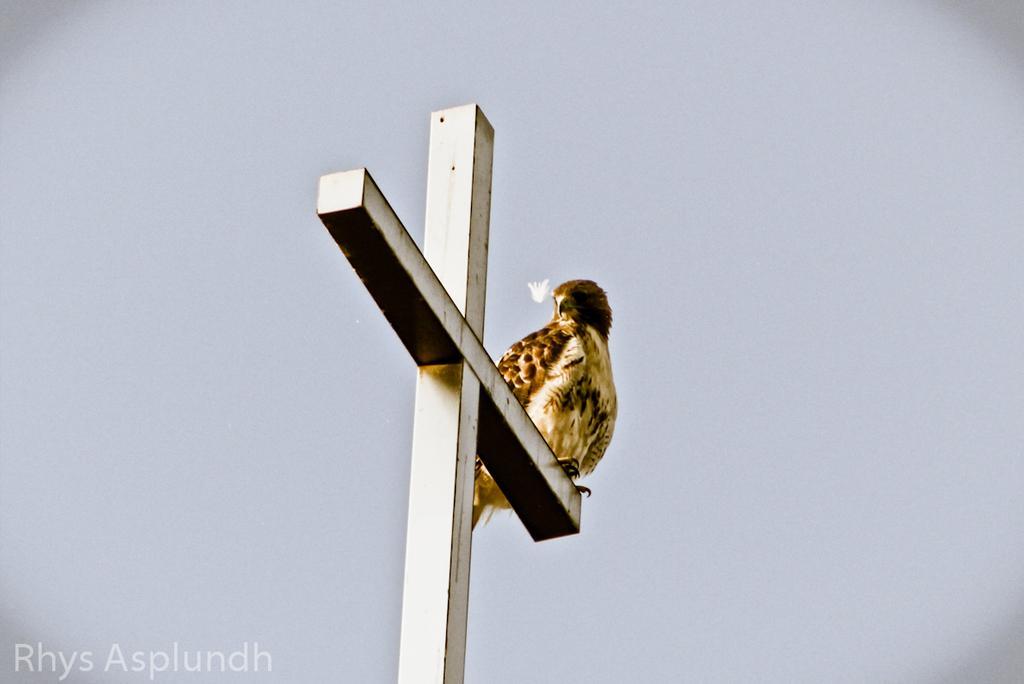In one or two sentences, can you explain what this image depicts? In this picture, we see a bird is on the pole. This pole looks like a crucifix. In the background, we see the sky. 